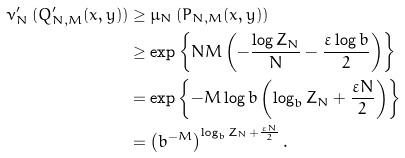Convert formula to latex. <formula><loc_0><loc_0><loc_500><loc_500>\nu ^ { \prime } _ { N } \left ( Q ^ { \prime } _ { N , M } ( x , y ) \right ) & \geq \mu _ { N } \left ( P _ { N , M } ( x , y ) \right ) \\ & \geq \exp \left \{ N M \left ( - \frac { \log Z _ { N } } { N } - \frac { \varepsilon \log b } { 2 } \right ) \right \} \\ & = \exp \left \{ - M \log b \left ( \log _ { b } Z _ { N } + \frac { \varepsilon N } { 2 } \right ) \right \} \\ & = \left ( b ^ { - M } \right ) ^ { \log _ { b } Z _ { N } + \frac { \varepsilon N } { 2 } } .</formula> 